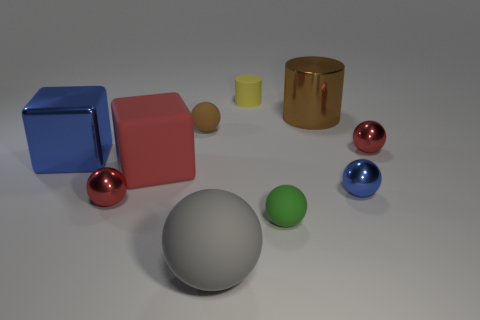How many small objects are the same color as the large matte sphere?
Offer a terse response. 0. What is the material of the big block to the right of the tiny red metal ball in front of the blue object that is to the right of the tiny yellow thing?
Keep it short and to the point. Rubber. How many blue things are either tiny matte objects or tiny objects?
Your answer should be very brief. 1. How big is the red cube that is behind the small red thing that is to the left of the red metallic object to the right of the brown cylinder?
Give a very brief answer. Large. There is a gray thing that is the same shape as the green object; what size is it?
Your response must be concise. Large. How many small objects are either green objects or red things?
Give a very brief answer. 3. Is the red object that is on the left side of the red block made of the same material as the cube in front of the blue metal block?
Your response must be concise. No. What is the big gray ball that is in front of the tiny yellow cylinder made of?
Your answer should be very brief. Rubber. How many rubber things are blue objects or balls?
Offer a very short reply. 3. What is the color of the big metal object in front of the tiny red object to the right of the brown metallic cylinder?
Provide a short and direct response. Blue. 